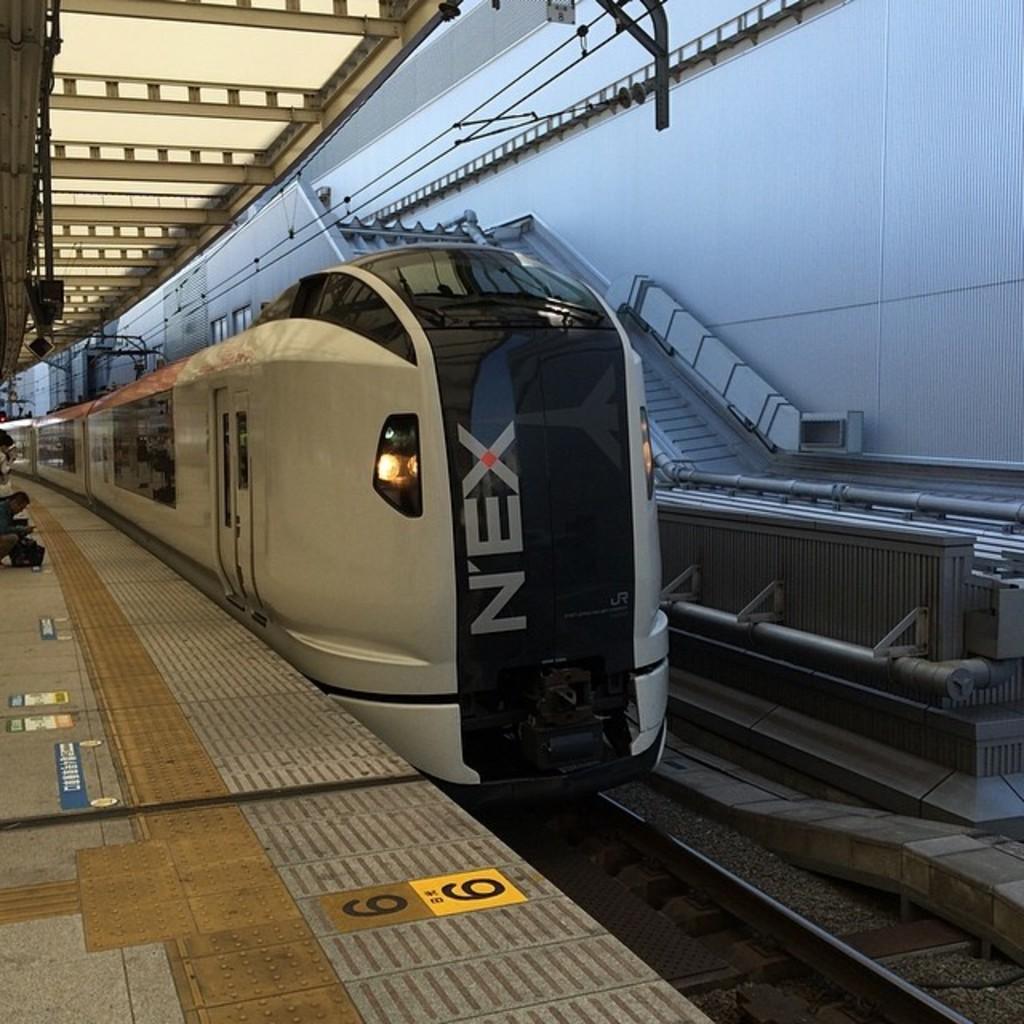Please provide a concise description of this image. In this picture we can see a train on a railway track, platform with some people on it, steps and in the background we can see rods. 